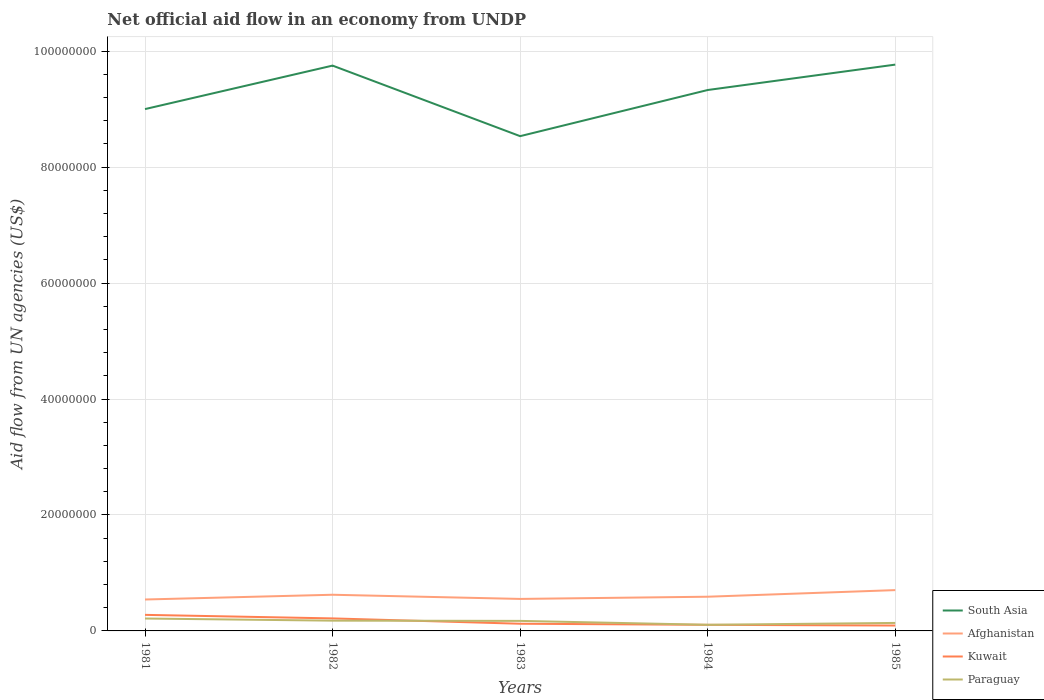Is the number of lines equal to the number of legend labels?
Make the answer very short. Yes. Across all years, what is the maximum net official aid flow in Afghanistan?
Give a very brief answer. 5.42e+06. In which year was the net official aid flow in Afghanistan maximum?
Provide a short and direct response. 1981. What is the total net official aid flow in South Asia in the graph?
Ensure brevity in your answer.  -1.70e+05. What is the difference between the highest and the second highest net official aid flow in Kuwait?
Keep it short and to the point. 1.84e+06. Is the net official aid flow in Paraguay strictly greater than the net official aid flow in South Asia over the years?
Offer a terse response. Yes. How many years are there in the graph?
Offer a very short reply. 5. Are the values on the major ticks of Y-axis written in scientific E-notation?
Give a very brief answer. No. Does the graph contain any zero values?
Ensure brevity in your answer.  No. How are the legend labels stacked?
Your response must be concise. Vertical. What is the title of the graph?
Your response must be concise. Net official aid flow in an economy from UNDP. What is the label or title of the Y-axis?
Your answer should be very brief. Aid flow from UN agencies (US$). What is the Aid flow from UN agencies (US$) in South Asia in 1981?
Make the answer very short. 9.00e+07. What is the Aid flow from UN agencies (US$) of Afghanistan in 1981?
Keep it short and to the point. 5.42e+06. What is the Aid flow from UN agencies (US$) of Kuwait in 1981?
Your answer should be compact. 2.77e+06. What is the Aid flow from UN agencies (US$) in Paraguay in 1981?
Your answer should be very brief. 2.14e+06. What is the Aid flow from UN agencies (US$) in South Asia in 1982?
Your response must be concise. 9.75e+07. What is the Aid flow from UN agencies (US$) of Afghanistan in 1982?
Offer a very short reply. 6.24e+06. What is the Aid flow from UN agencies (US$) in Kuwait in 1982?
Give a very brief answer. 2.16e+06. What is the Aid flow from UN agencies (US$) in Paraguay in 1982?
Keep it short and to the point. 1.77e+06. What is the Aid flow from UN agencies (US$) of South Asia in 1983?
Give a very brief answer. 8.54e+07. What is the Aid flow from UN agencies (US$) in Afghanistan in 1983?
Offer a very short reply. 5.52e+06. What is the Aid flow from UN agencies (US$) in Kuwait in 1983?
Make the answer very short. 1.24e+06. What is the Aid flow from UN agencies (US$) in Paraguay in 1983?
Your answer should be very brief. 1.73e+06. What is the Aid flow from UN agencies (US$) in South Asia in 1984?
Offer a very short reply. 9.33e+07. What is the Aid flow from UN agencies (US$) in Afghanistan in 1984?
Offer a very short reply. 5.90e+06. What is the Aid flow from UN agencies (US$) of Kuwait in 1984?
Ensure brevity in your answer.  1.05e+06. What is the Aid flow from UN agencies (US$) of Paraguay in 1984?
Provide a succinct answer. 1.06e+06. What is the Aid flow from UN agencies (US$) in South Asia in 1985?
Provide a succinct answer. 9.77e+07. What is the Aid flow from UN agencies (US$) in Afghanistan in 1985?
Keep it short and to the point. 7.04e+06. What is the Aid flow from UN agencies (US$) in Kuwait in 1985?
Keep it short and to the point. 9.30e+05. What is the Aid flow from UN agencies (US$) of Paraguay in 1985?
Make the answer very short. 1.38e+06. Across all years, what is the maximum Aid flow from UN agencies (US$) in South Asia?
Keep it short and to the point. 9.77e+07. Across all years, what is the maximum Aid flow from UN agencies (US$) of Afghanistan?
Offer a very short reply. 7.04e+06. Across all years, what is the maximum Aid flow from UN agencies (US$) in Kuwait?
Offer a terse response. 2.77e+06. Across all years, what is the maximum Aid flow from UN agencies (US$) of Paraguay?
Keep it short and to the point. 2.14e+06. Across all years, what is the minimum Aid flow from UN agencies (US$) of South Asia?
Your answer should be very brief. 8.54e+07. Across all years, what is the minimum Aid flow from UN agencies (US$) in Afghanistan?
Give a very brief answer. 5.42e+06. Across all years, what is the minimum Aid flow from UN agencies (US$) in Kuwait?
Your answer should be compact. 9.30e+05. Across all years, what is the minimum Aid flow from UN agencies (US$) in Paraguay?
Ensure brevity in your answer.  1.06e+06. What is the total Aid flow from UN agencies (US$) of South Asia in the graph?
Your answer should be very brief. 4.64e+08. What is the total Aid flow from UN agencies (US$) in Afghanistan in the graph?
Ensure brevity in your answer.  3.01e+07. What is the total Aid flow from UN agencies (US$) in Kuwait in the graph?
Provide a succinct answer. 8.15e+06. What is the total Aid flow from UN agencies (US$) in Paraguay in the graph?
Ensure brevity in your answer.  8.08e+06. What is the difference between the Aid flow from UN agencies (US$) of South Asia in 1981 and that in 1982?
Offer a very short reply. -7.50e+06. What is the difference between the Aid flow from UN agencies (US$) of Afghanistan in 1981 and that in 1982?
Provide a short and direct response. -8.20e+05. What is the difference between the Aid flow from UN agencies (US$) in Kuwait in 1981 and that in 1982?
Make the answer very short. 6.10e+05. What is the difference between the Aid flow from UN agencies (US$) in South Asia in 1981 and that in 1983?
Offer a very short reply. 4.67e+06. What is the difference between the Aid flow from UN agencies (US$) in Kuwait in 1981 and that in 1983?
Give a very brief answer. 1.53e+06. What is the difference between the Aid flow from UN agencies (US$) in Paraguay in 1981 and that in 1983?
Offer a very short reply. 4.10e+05. What is the difference between the Aid flow from UN agencies (US$) of South Asia in 1981 and that in 1984?
Your response must be concise. -3.29e+06. What is the difference between the Aid flow from UN agencies (US$) in Afghanistan in 1981 and that in 1984?
Provide a short and direct response. -4.80e+05. What is the difference between the Aid flow from UN agencies (US$) of Kuwait in 1981 and that in 1984?
Make the answer very short. 1.72e+06. What is the difference between the Aid flow from UN agencies (US$) of Paraguay in 1981 and that in 1984?
Give a very brief answer. 1.08e+06. What is the difference between the Aid flow from UN agencies (US$) in South Asia in 1981 and that in 1985?
Offer a very short reply. -7.67e+06. What is the difference between the Aid flow from UN agencies (US$) in Afghanistan in 1981 and that in 1985?
Your response must be concise. -1.62e+06. What is the difference between the Aid flow from UN agencies (US$) in Kuwait in 1981 and that in 1985?
Your response must be concise. 1.84e+06. What is the difference between the Aid flow from UN agencies (US$) of Paraguay in 1981 and that in 1985?
Ensure brevity in your answer.  7.60e+05. What is the difference between the Aid flow from UN agencies (US$) in South Asia in 1982 and that in 1983?
Your answer should be compact. 1.22e+07. What is the difference between the Aid flow from UN agencies (US$) of Afghanistan in 1982 and that in 1983?
Your answer should be compact. 7.20e+05. What is the difference between the Aid flow from UN agencies (US$) in Kuwait in 1982 and that in 1983?
Give a very brief answer. 9.20e+05. What is the difference between the Aid flow from UN agencies (US$) in South Asia in 1982 and that in 1984?
Ensure brevity in your answer.  4.21e+06. What is the difference between the Aid flow from UN agencies (US$) in Afghanistan in 1982 and that in 1984?
Your response must be concise. 3.40e+05. What is the difference between the Aid flow from UN agencies (US$) of Kuwait in 1982 and that in 1984?
Offer a very short reply. 1.11e+06. What is the difference between the Aid flow from UN agencies (US$) in Paraguay in 1982 and that in 1984?
Make the answer very short. 7.10e+05. What is the difference between the Aid flow from UN agencies (US$) of South Asia in 1982 and that in 1985?
Give a very brief answer. -1.70e+05. What is the difference between the Aid flow from UN agencies (US$) in Afghanistan in 1982 and that in 1985?
Your answer should be very brief. -8.00e+05. What is the difference between the Aid flow from UN agencies (US$) in Kuwait in 1982 and that in 1985?
Ensure brevity in your answer.  1.23e+06. What is the difference between the Aid flow from UN agencies (US$) of South Asia in 1983 and that in 1984?
Your answer should be very brief. -7.96e+06. What is the difference between the Aid flow from UN agencies (US$) in Afghanistan in 1983 and that in 1984?
Keep it short and to the point. -3.80e+05. What is the difference between the Aid flow from UN agencies (US$) in Paraguay in 1983 and that in 1984?
Keep it short and to the point. 6.70e+05. What is the difference between the Aid flow from UN agencies (US$) in South Asia in 1983 and that in 1985?
Offer a terse response. -1.23e+07. What is the difference between the Aid flow from UN agencies (US$) of Afghanistan in 1983 and that in 1985?
Provide a short and direct response. -1.52e+06. What is the difference between the Aid flow from UN agencies (US$) in Kuwait in 1983 and that in 1985?
Make the answer very short. 3.10e+05. What is the difference between the Aid flow from UN agencies (US$) in South Asia in 1984 and that in 1985?
Keep it short and to the point. -4.38e+06. What is the difference between the Aid flow from UN agencies (US$) in Afghanistan in 1984 and that in 1985?
Keep it short and to the point. -1.14e+06. What is the difference between the Aid flow from UN agencies (US$) of Paraguay in 1984 and that in 1985?
Your answer should be compact. -3.20e+05. What is the difference between the Aid flow from UN agencies (US$) in South Asia in 1981 and the Aid flow from UN agencies (US$) in Afghanistan in 1982?
Ensure brevity in your answer.  8.38e+07. What is the difference between the Aid flow from UN agencies (US$) of South Asia in 1981 and the Aid flow from UN agencies (US$) of Kuwait in 1982?
Keep it short and to the point. 8.79e+07. What is the difference between the Aid flow from UN agencies (US$) in South Asia in 1981 and the Aid flow from UN agencies (US$) in Paraguay in 1982?
Your answer should be very brief. 8.82e+07. What is the difference between the Aid flow from UN agencies (US$) of Afghanistan in 1981 and the Aid flow from UN agencies (US$) of Kuwait in 1982?
Keep it short and to the point. 3.26e+06. What is the difference between the Aid flow from UN agencies (US$) of Afghanistan in 1981 and the Aid flow from UN agencies (US$) of Paraguay in 1982?
Your answer should be very brief. 3.65e+06. What is the difference between the Aid flow from UN agencies (US$) of South Asia in 1981 and the Aid flow from UN agencies (US$) of Afghanistan in 1983?
Keep it short and to the point. 8.45e+07. What is the difference between the Aid flow from UN agencies (US$) in South Asia in 1981 and the Aid flow from UN agencies (US$) in Kuwait in 1983?
Keep it short and to the point. 8.88e+07. What is the difference between the Aid flow from UN agencies (US$) of South Asia in 1981 and the Aid flow from UN agencies (US$) of Paraguay in 1983?
Your answer should be compact. 8.83e+07. What is the difference between the Aid flow from UN agencies (US$) of Afghanistan in 1981 and the Aid flow from UN agencies (US$) of Kuwait in 1983?
Provide a short and direct response. 4.18e+06. What is the difference between the Aid flow from UN agencies (US$) of Afghanistan in 1981 and the Aid flow from UN agencies (US$) of Paraguay in 1983?
Offer a terse response. 3.69e+06. What is the difference between the Aid flow from UN agencies (US$) in Kuwait in 1981 and the Aid flow from UN agencies (US$) in Paraguay in 1983?
Make the answer very short. 1.04e+06. What is the difference between the Aid flow from UN agencies (US$) of South Asia in 1981 and the Aid flow from UN agencies (US$) of Afghanistan in 1984?
Ensure brevity in your answer.  8.41e+07. What is the difference between the Aid flow from UN agencies (US$) in South Asia in 1981 and the Aid flow from UN agencies (US$) in Kuwait in 1984?
Provide a short and direct response. 8.90e+07. What is the difference between the Aid flow from UN agencies (US$) of South Asia in 1981 and the Aid flow from UN agencies (US$) of Paraguay in 1984?
Keep it short and to the point. 8.90e+07. What is the difference between the Aid flow from UN agencies (US$) of Afghanistan in 1981 and the Aid flow from UN agencies (US$) of Kuwait in 1984?
Provide a short and direct response. 4.37e+06. What is the difference between the Aid flow from UN agencies (US$) in Afghanistan in 1981 and the Aid flow from UN agencies (US$) in Paraguay in 1984?
Ensure brevity in your answer.  4.36e+06. What is the difference between the Aid flow from UN agencies (US$) of Kuwait in 1981 and the Aid flow from UN agencies (US$) of Paraguay in 1984?
Provide a short and direct response. 1.71e+06. What is the difference between the Aid flow from UN agencies (US$) of South Asia in 1981 and the Aid flow from UN agencies (US$) of Afghanistan in 1985?
Your response must be concise. 8.30e+07. What is the difference between the Aid flow from UN agencies (US$) in South Asia in 1981 and the Aid flow from UN agencies (US$) in Kuwait in 1985?
Your answer should be compact. 8.91e+07. What is the difference between the Aid flow from UN agencies (US$) of South Asia in 1981 and the Aid flow from UN agencies (US$) of Paraguay in 1985?
Your answer should be compact. 8.86e+07. What is the difference between the Aid flow from UN agencies (US$) in Afghanistan in 1981 and the Aid flow from UN agencies (US$) in Kuwait in 1985?
Ensure brevity in your answer.  4.49e+06. What is the difference between the Aid flow from UN agencies (US$) in Afghanistan in 1981 and the Aid flow from UN agencies (US$) in Paraguay in 1985?
Offer a very short reply. 4.04e+06. What is the difference between the Aid flow from UN agencies (US$) of Kuwait in 1981 and the Aid flow from UN agencies (US$) of Paraguay in 1985?
Your answer should be compact. 1.39e+06. What is the difference between the Aid flow from UN agencies (US$) of South Asia in 1982 and the Aid flow from UN agencies (US$) of Afghanistan in 1983?
Keep it short and to the point. 9.20e+07. What is the difference between the Aid flow from UN agencies (US$) of South Asia in 1982 and the Aid flow from UN agencies (US$) of Kuwait in 1983?
Provide a succinct answer. 9.63e+07. What is the difference between the Aid flow from UN agencies (US$) in South Asia in 1982 and the Aid flow from UN agencies (US$) in Paraguay in 1983?
Offer a terse response. 9.58e+07. What is the difference between the Aid flow from UN agencies (US$) of Afghanistan in 1982 and the Aid flow from UN agencies (US$) of Paraguay in 1983?
Provide a succinct answer. 4.51e+06. What is the difference between the Aid flow from UN agencies (US$) of South Asia in 1982 and the Aid flow from UN agencies (US$) of Afghanistan in 1984?
Provide a succinct answer. 9.16e+07. What is the difference between the Aid flow from UN agencies (US$) of South Asia in 1982 and the Aid flow from UN agencies (US$) of Kuwait in 1984?
Your answer should be compact. 9.65e+07. What is the difference between the Aid flow from UN agencies (US$) in South Asia in 1982 and the Aid flow from UN agencies (US$) in Paraguay in 1984?
Offer a terse response. 9.65e+07. What is the difference between the Aid flow from UN agencies (US$) in Afghanistan in 1982 and the Aid flow from UN agencies (US$) in Kuwait in 1984?
Your answer should be very brief. 5.19e+06. What is the difference between the Aid flow from UN agencies (US$) in Afghanistan in 1982 and the Aid flow from UN agencies (US$) in Paraguay in 1984?
Your response must be concise. 5.18e+06. What is the difference between the Aid flow from UN agencies (US$) in Kuwait in 1982 and the Aid flow from UN agencies (US$) in Paraguay in 1984?
Offer a terse response. 1.10e+06. What is the difference between the Aid flow from UN agencies (US$) in South Asia in 1982 and the Aid flow from UN agencies (US$) in Afghanistan in 1985?
Your answer should be very brief. 9.05e+07. What is the difference between the Aid flow from UN agencies (US$) of South Asia in 1982 and the Aid flow from UN agencies (US$) of Kuwait in 1985?
Offer a terse response. 9.66e+07. What is the difference between the Aid flow from UN agencies (US$) in South Asia in 1982 and the Aid flow from UN agencies (US$) in Paraguay in 1985?
Offer a very short reply. 9.61e+07. What is the difference between the Aid flow from UN agencies (US$) of Afghanistan in 1982 and the Aid flow from UN agencies (US$) of Kuwait in 1985?
Offer a terse response. 5.31e+06. What is the difference between the Aid flow from UN agencies (US$) in Afghanistan in 1982 and the Aid flow from UN agencies (US$) in Paraguay in 1985?
Provide a succinct answer. 4.86e+06. What is the difference between the Aid flow from UN agencies (US$) of Kuwait in 1982 and the Aid flow from UN agencies (US$) of Paraguay in 1985?
Provide a short and direct response. 7.80e+05. What is the difference between the Aid flow from UN agencies (US$) of South Asia in 1983 and the Aid flow from UN agencies (US$) of Afghanistan in 1984?
Provide a succinct answer. 7.94e+07. What is the difference between the Aid flow from UN agencies (US$) in South Asia in 1983 and the Aid flow from UN agencies (US$) in Kuwait in 1984?
Make the answer very short. 8.43e+07. What is the difference between the Aid flow from UN agencies (US$) in South Asia in 1983 and the Aid flow from UN agencies (US$) in Paraguay in 1984?
Provide a succinct answer. 8.43e+07. What is the difference between the Aid flow from UN agencies (US$) of Afghanistan in 1983 and the Aid flow from UN agencies (US$) of Kuwait in 1984?
Your answer should be very brief. 4.47e+06. What is the difference between the Aid flow from UN agencies (US$) in Afghanistan in 1983 and the Aid flow from UN agencies (US$) in Paraguay in 1984?
Offer a terse response. 4.46e+06. What is the difference between the Aid flow from UN agencies (US$) of South Asia in 1983 and the Aid flow from UN agencies (US$) of Afghanistan in 1985?
Your answer should be very brief. 7.83e+07. What is the difference between the Aid flow from UN agencies (US$) of South Asia in 1983 and the Aid flow from UN agencies (US$) of Kuwait in 1985?
Your answer should be compact. 8.44e+07. What is the difference between the Aid flow from UN agencies (US$) of South Asia in 1983 and the Aid flow from UN agencies (US$) of Paraguay in 1985?
Your answer should be compact. 8.40e+07. What is the difference between the Aid flow from UN agencies (US$) in Afghanistan in 1983 and the Aid flow from UN agencies (US$) in Kuwait in 1985?
Provide a succinct answer. 4.59e+06. What is the difference between the Aid flow from UN agencies (US$) in Afghanistan in 1983 and the Aid flow from UN agencies (US$) in Paraguay in 1985?
Provide a short and direct response. 4.14e+06. What is the difference between the Aid flow from UN agencies (US$) in Kuwait in 1983 and the Aid flow from UN agencies (US$) in Paraguay in 1985?
Your answer should be compact. -1.40e+05. What is the difference between the Aid flow from UN agencies (US$) of South Asia in 1984 and the Aid flow from UN agencies (US$) of Afghanistan in 1985?
Make the answer very short. 8.63e+07. What is the difference between the Aid flow from UN agencies (US$) of South Asia in 1984 and the Aid flow from UN agencies (US$) of Kuwait in 1985?
Give a very brief answer. 9.24e+07. What is the difference between the Aid flow from UN agencies (US$) in South Asia in 1984 and the Aid flow from UN agencies (US$) in Paraguay in 1985?
Provide a short and direct response. 9.19e+07. What is the difference between the Aid flow from UN agencies (US$) in Afghanistan in 1984 and the Aid flow from UN agencies (US$) in Kuwait in 1985?
Make the answer very short. 4.97e+06. What is the difference between the Aid flow from UN agencies (US$) in Afghanistan in 1984 and the Aid flow from UN agencies (US$) in Paraguay in 1985?
Keep it short and to the point. 4.52e+06. What is the difference between the Aid flow from UN agencies (US$) of Kuwait in 1984 and the Aid flow from UN agencies (US$) of Paraguay in 1985?
Provide a short and direct response. -3.30e+05. What is the average Aid flow from UN agencies (US$) in South Asia per year?
Offer a very short reply. 9.28e+07. What is the average Aid flow from UN agencies (US$) of Afghanistan per year?
Your response must be concise. 6.02e+06. What is the average Aid flow from UN agencies (US$) of Kuwait per year?
Offer a terse response. 1.63e+06. What is the average Aid flow from UN agencies (US$) in Paraguay per year?
Provide a succinct answer. 1.62e+06. In the year 1981, what is the difference between the Aid flow from UN agencies (US$) of South Asia and Aid flow from UN agencies (US$) of Afghanistan?
Offer a very short reply. 8.46e+07. In the year 1981, what is the difference between the Aid flow from UN agencies (US$) of South Asia and Aid flow from UN agencies (US$) of Kuwait?
Give a very brief answer. 8.72e+07. In the year 1981, what is the difference between the Aid flow from UN agencies (US$) of South Asia and Aid flow from UN agencies (US$) of Paraguay?
Your answer should be very brief. 8.79e+07. In the year 1981, what is the difference between the Aid flow from UN agencies (US$) in Afghanistan and Aid flow from UN agencies (US$) in Kuwait?
Give a very brief answer. 2.65e+06. In the year 1981, what is the difference between the Aid flow from UN agencies (US$) in Afghanistan and Aid flow from UN agencies (US$) in Paraguay?
Keep it short and to the point. 3.28e+06. In the year 1981, what is the difference between the Aid flow from UN agencies (US$) in Kuwait and Aid flow from UN agencies (US$) in Paraguay?
Ensure brevity in your answer.  6.30e+05. In the year 1982, what is the difference between the Aid flow from UN agencies (US$) of South Asia and Aid flow from UN agencies (US$) of Afghanistan?
Provide a short and direct response. 9.13e+07. In the year 1982, what is the difference between the Aid flow from UN agencies (US$) of South Asia and Aid flow from UN agencies (US$) of Kuwait?
Ensure brevity in your answer.  9.54e+07. In the year 1982, what is the difference between the Aid flow from UN agencies (US$) in South Asia and Aid flow from UN agencies (US$) in Paraguay?
Your response must be concise. 9.58e+07. In the year 1982, what is the difference between the Aid flow from UN agencies (US$) of Afghanistan and Aid flow from UN agencies (US$) of Kuwait?
Give a very brief answer. 4.08e+06. In the year 1982, what is the difference between the Aid flow from UN agencies (US$) in Afghanistan and Aid flow from UN agencies (US$) in Paraguay?
Your answer should be very brief. 4.47e+06. In the year 1983, what is the difference between the Aid flow from UN agencies (US$) of South Asia and Aid flow from UN agencies (US$) of Afghanistan?
Your response must be concise. 7.98e+07. In the year 1983, what is the difference between the Aid flow from UN agencies (US$) of South Asia and Aid flow from UN agencies (US$) of Kuwait?
Your response must be concise. 8.41e+07. In the year 1983, what is the difference between the Aid flow from UN agencies (US$) in South Asia and Aid flow from UN agencies (US$) in Paraguay?
Ensure brevity in your answer.  8.36e+07. In the year 1983, what is the difference between the Aid flow from UN agencies (US$) in Afghanistan and Aid flow from UN agencies (US$) in Kuwait?
Make the answer very short. 4.28e+06. In the year 1983, what is the difference between the Aid flow from UN agencies (US$) in Afghanistan and Aid flow from UN agencies (US$) in Paraguay?
Give a very brief answer. 3.79e+06. In the year 1983, what is the difference between the Aid flow from UN agencies (US$) of Kuwait and Aid flow from UN agencies (US$) of Paraguay?
Keep it short and to the point. -4.90e+05. In the year 1984, what is the difference between the Aid flow from UN agencies (US$) in South Asia and Aid flow from UN agencies (US$) in Afghanistan?
Give a very brief answer. 8.74e+07. In the year 1984, what is the difference between the Aid flow from UN agencies (US$) in South Asia and Aid flow from UN agencies (US$) in Kuwait?
Ensure brevity in your answer.  9.23e+07. In the year 1984, what is the difference between the Aid flow from UN agencies (US$) of South Asia and Aid flow from UN agencies (US$) of Paraguay?
Provide a short and direct response. 9.22e+07. In the year 1984, what is the difference between the Aid flow from UN agencies (US$) in Afghanistan and Aid flow from UN agencies (US$) in Kuwait?
Provide a succinct answer. 4.85e+06. In the year 1984, what is the difference between the Aid flow from UN agencies (US$) in Afghanistan and Aid flow from UN agencies (US$) in Paraguay?
Keep it short and to the point. 4.84e+06. In the year 1984, what is the difference between the Aid flow from UN agencies (US$) of Kuwait and Aid flow from UN agencies (US$) of Paraguay?
Offer a very short reply. -10000. In the year 1985, what is the difference between the Aid flow from UN agencies (US$) of South Asia and Aid flow from UN agencies (US$) of Afghanistan?
Offer a very short reply. 9.06e+07. In the year 1985, what is the difference between the Aid flow from UN agencies (US$) in South Asia and Aid flow from UN agencies (US$) in Kuwait?
Your answer should be compact. 9.68e+07. In the year 1985, what is the difference between the Aid flow from UN agencies (US$) of South Asia and Aid flow from UN agencies (US$) of Paraguay?
Offer a very short reply. 9.63e+07. In the year 1985, what is the difference between the Aid flow from UN agencies (US$) of Afghanistan and Aid flow from UN agencies (US$) of Kuwait?
Keep it short and to the point. 6.11e+06. In the year 1985, what is the difference between the Aid flow from UN agencies (US$) of Afghanistan and Aid flow from UN agencies (US$) of Paraguay?
Your answer should be very brief. 5.66e+06. In the year 1985, what is the difference between the Aid flow from UN agencies (US$) of Kuwait and Aid flow from UN agencies (US$) of Paraguay?
Offer a terse response. -4.50e+05. What is the ratio of the Aid flow from UN agencies (US$) in Afghanistan in 1981 to that in 1982?
Your answer should be very brief. 0.87. What is the ratio of the Aid flow from UN agencies (US$) in Kuwait in 1981 to that in 1982?
Your response must be concise. 1.28. What is the ratio of the Aid flow from UN agencies (US$) of Paraguay in 1981 to that in 1982?
Offer a very short reply. 1.21. What is the ratio of the Aid flow from UN agencies (US$) of South Asia in 1981 to that in 1983?
Offer a very short reply. 1.05. What is the ratio of the Aid flow from UN agencies (US$) of Afghanistan in 1981 to that in 1983?
Your answer should be very brief. 0.98. What is the ratio of the Aid flow from UN agencies (US$) of Kuwait in 1981 to that in 1983?
Keep it short and to the point. 2.23. What is the ratio of the Aid flow from UN agencies (US$) in Paraguay in 1981 to that in 1983?
Provide a succinct answer. 1.24. What is the ratio of the Aid flow from UN agencies (US$) in South Asia in 1981 to that in 1984?
Provide a succinct answer. 0.96. What is the ratio of the Aid flow from UN agencies (US$) in Afghanistan in 1981 to that in 1984?
Your response must be concise. 0.92. What is the ratio of the Aid flow from UN agencies (US$) in Kuwait in 1981 to that in 1984?
Offer a terse response. 2.64. What is the ratio of the Aid flow from UN agencies (US$) of Paraguay in 1981 to that in 1984?
Give a very brief answer. 2.02. What is the ratio of the Aid flow from UN agencies (US$) in South Asia in 1981 to that in 1985?
Your answer should be compact. 0.92. What is the ratio of the Aid flow from UN agencies (US$) in Afghanistan in 1981 to that in 1985?
Keep it short and to the point. 0.77. What is the ratio of the Aid flow from UN agencies (US$) in Kuwait in 1981 to that in 1985?
Provide a short and direct response. 2.98. What is the ratio of the Aid flow from UN agencies (US$) of Paraguay in 1981 to that in 1985?
Make the answer very short. 1.55. What is the ratio of the Aid flow from UN agencies (US$) in South Asia in 1982 to that in 1983?
Your response must be concise. 1.14. What is the ratio of the Aid flow from UN agencies (US$) of Afghanistan in 1982 to that in 1983?
Your answer should be compact. 1.13. What is the ratio of the Aid flow from UN agencies (US$) of Kuwait in 1982 to that in 1983?
Make the answer very short. 1.74. What is the ratio of the Aid flow from UN agencies (US$) of Paraguay in 1982 to that in 1983?
Make the answer very short. 1.02. What is the ratio of the Aid flow from UN agencies (US$) in South Asia in 1982 to that in 1984?
Offer a terse response. 1.05. What is the ratio of the Aid flow from UN agencies (US$) of Afghanistan in 1982 to that in 1984?
Your response must be concise. 1.06. What is the ratio of the Aid flow from UN agencies (US$) in Kuwait in 1982 to that in 1984?
Your answer should be compact. 2.06. What is the ratio of the Aid flow from UN agencies (US$) in Paraguay in 1982 to that in 1984?
Provide a succinct answer. 1.67. What is the ratio of the Aid flow from UN agencies (US$) of South Asia in 1982 to that in 1985?
Your answer should be compact. 1. What is the ratio of the Aid flow from UN agencies (US$) in Afghanistan in 1982 to that in 1985?
Keep it short and to the point. 0.89. What is the ratio of the Aid flow from UN agencies (US$) in Kuwait in 1982 to that in 1985?
Your answer should be compact. 2.32. What is the ratio of the Aid flow from UN agencies (US$) in Paraguay in 1982 to that in 1985?
Ensure brevity in your answer.  1.28. What is the ratio of the Aid flow from UN agencies (US$) of South Asia in 1983 to that in 1984?
Offer a terse response. 0.91. What is the ratio of the Aid flow from UN agencies (US$) of Afghanistan in 1983 to that in 1984?
Ensure brevity in your answer.  0.94. What is the ratio of the Aid flow from UN agencies (US$) in Kuwait in 1983 to that in 1984?
Your answer should be very brief. 1.18. What is the ratio of the Aid flow from UN agencies (US$) of Paraguay in 1983 to that in 1984?
Your response must be concise. 1.63. What is the ratio of the Aid flow from UN agencies (US$) of South Asia in 1983 to that in 1985?
Offer a very short reply. 0.87. What is the ratio of the Aid flow from UN agencies (US$) in Afghanistan in 1983 to that in 1985?
Give a very brief answer. 0.78. What is the ratio of the Aid flow from UN agencies (US$) of Kuwait in 1983 to that in 1985?
Your answer should be compact. 1.33. What is the ratio of the Aid flow from UN agencies (US$) of Paraguay in 1983 to that in 1985?
Your answer should be very brief. 1.25. What is the ratio of the Aid flow from UN agencies (US$) of South Asia in 1984 to that in 1985?
Provide a succinct answer. 0.96. What is the ratio of the Aid flow from UN agencies (US$) in Afghanistan in 1984 to that in 1985?
Offer a very short reply. 0.84. What is the ratio of the Aid flow from UN agencies (US$) of Kuwait in 1984 to that in 1985?
Make the answer very short. 1.13. What is the ratio of the Aid flow from UN agencies (US$) of Paraguay in 1984 to that in 1985?
Keep it short and to the point. 0.77. What is the difference between the highest and the second highest Aid flow from UN agencies (US$) of Afghanistan?
Your response must be concise. 8.00e+05. What is the difference between the highest and the second highest Aid flow from UN agencies (US$) in Paraguay?
Your answer should be very brief. 3.70e+05. What is the difference between the highest and the lowest Aid flow from UN agencies (US$) of South Asia?
Provide a short and direct response. 1.23e+07. What is the difference between the highest and the lowest Aid flow from UN agencies (US$) of Afghanistan?
Make the answer very short. 1.62e+06. What is the difference between the highest and the lowest Aid flow from UN agencies (US$) in Kuwait?
Keep it short and to the point. 1.84e+06. What is the difference between the highest and the lowest Aid flow from UN agencies (US$) in Paraguay?
Your answer should be very brief. 1.08e+06. 